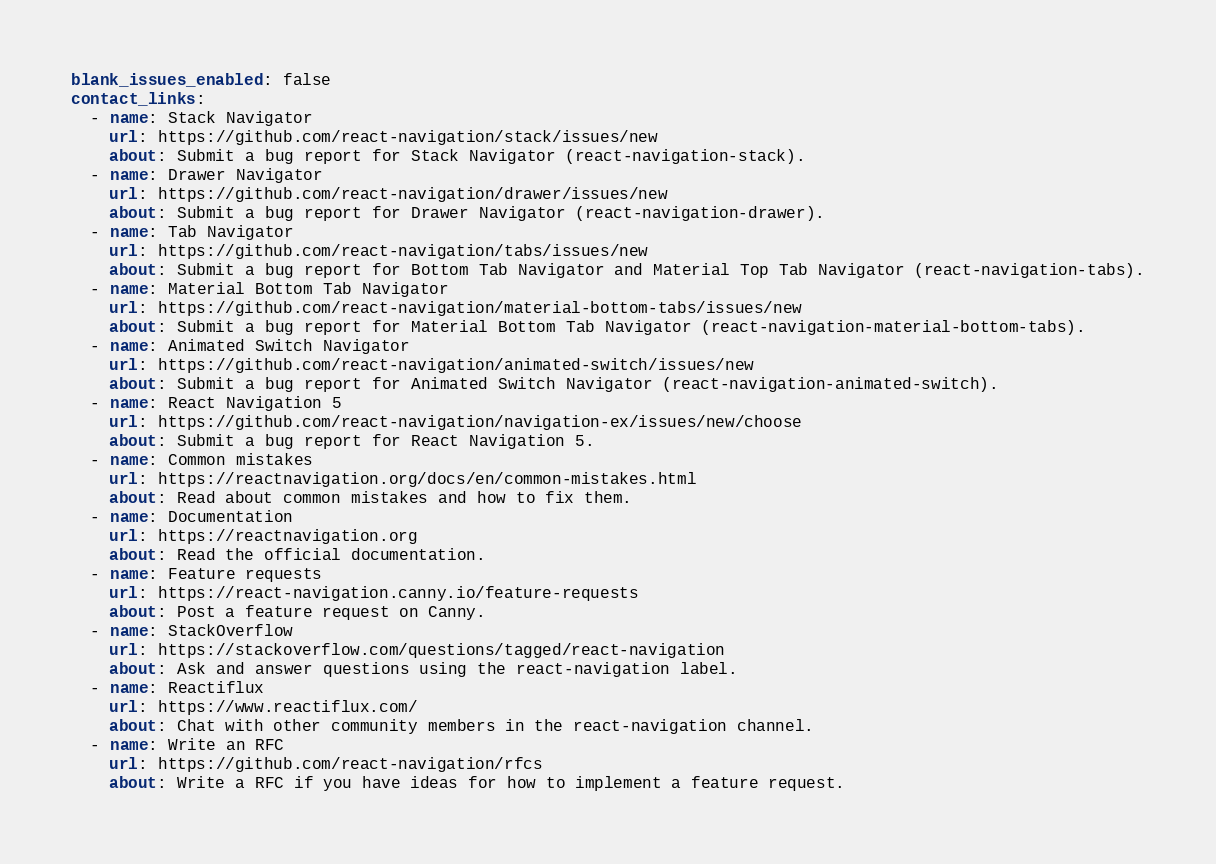<code> <loc_0><loc_0><loc_500><loc_500><_YAML_>blank_issues_enabled: false
contact_links:
  - name: Stack Navigator
    url: https://github.com/react-navigation/stack/issues/new
    about: Submit a bug report for Stack Navigator (react-navigation-stack).
  - name: Drawer Navigator
    url: https://github.com/react-navigation/drawer/issues/new
    about: Submit a bug report for Drawer Navigator (react-navigation-drawer).
  - name: Tab Navigator
    url: https://github.com/react-navigation/tabs/issues/new
    about: Submit a bug report for Bottom Tab Navigator and Material Top Tab Navigator (react-navigation-tabs).
  - name: Material Bottom Tab Navigator
    url: https://github.com/react-navigation/material-bottom-tabs/issues/new
    about: Submit a bug report for Material Bottom Tab Navigator (react-navigation-material-bottom-tabs).
  - name: Animated Switch Navigator
    url: https://github.com/react-navigation/animated-switch/issues/new
    about: Submit a bug report for Animated Switch Navigator (react-navigation-animated-switch).
  - name: React Navigation 5
    url: https://github.com/react-navigation/navigation-ex/issues/new/choose
    about: Submit a bug report for React Navigation 5.
  - name: Common mistakes
    url: https://reactnavigation.org/docs/en/common-mistakes.html
    about: Read about common mistakes and how to fix them.
  - name: Documentation
    url: https://reactnavigation.org
    about: Read the official documentation.
  - name: Feature requests
    url: https://react-navigation.canny.io/feature-requests
    about: Post a feature request on Canny.
  - name: StackOverflow
    url: https://stackoverflow.com/questions/tagged/react-navigation
    about: Ask and answer questions using the react-navigation label.
  - name: Reactiflux
    url: https://www.reactiflux.com/
    about: Chat with other community members in the react-navigation channel.
  - name: Write an RFC
    url: https://github.com/react-navigation/rfcs
    about: Write a RFC if you have ideas for how to implement a feature request.
</code> 